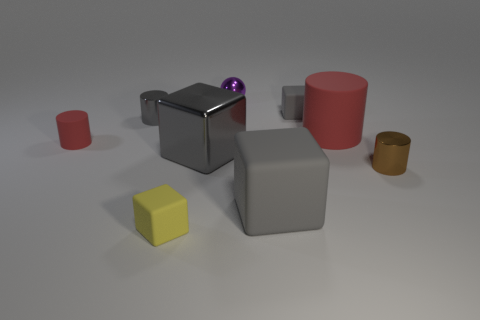Subtract all matte cubes. How many cubes are left? 1 Subtract all cyan spheres. How many red cylinders are left? 2 Subtract all gray cylinders. How many cylinders are left? 3 Subtract all blocks. How many objects are left? 5 Subtract 0 green cylinders. How many objects are left? 9 Subtract all green balls. Subtract all yellow cylinders. How many balls are left? 1 Subtract all matte things. Subtract all yellow rubber objects. How many objects are left? 3 Add 9 tiny red objects. How many tiny red objects are left? 10 Add 3 small shiny spheres. How many small shiny spheres exist? 4 